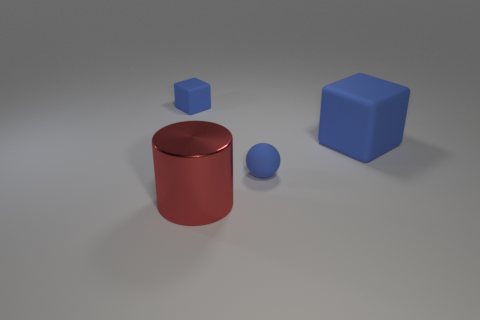Add 3 large red cylinders. How many objects exist? 7 Subtract all balls. How many objects are left? 3 Subtract all small gray shiny cubes. Subtract all small blocks. How many objects are left? 3 Add 3 large metallic cylinders. How many large metallic cylinders are left? 4 Add 2 purple metallic spheres. How many purple metallic spheres exist? 2 Subtract 0 brown balls. How many objects are left? 4 